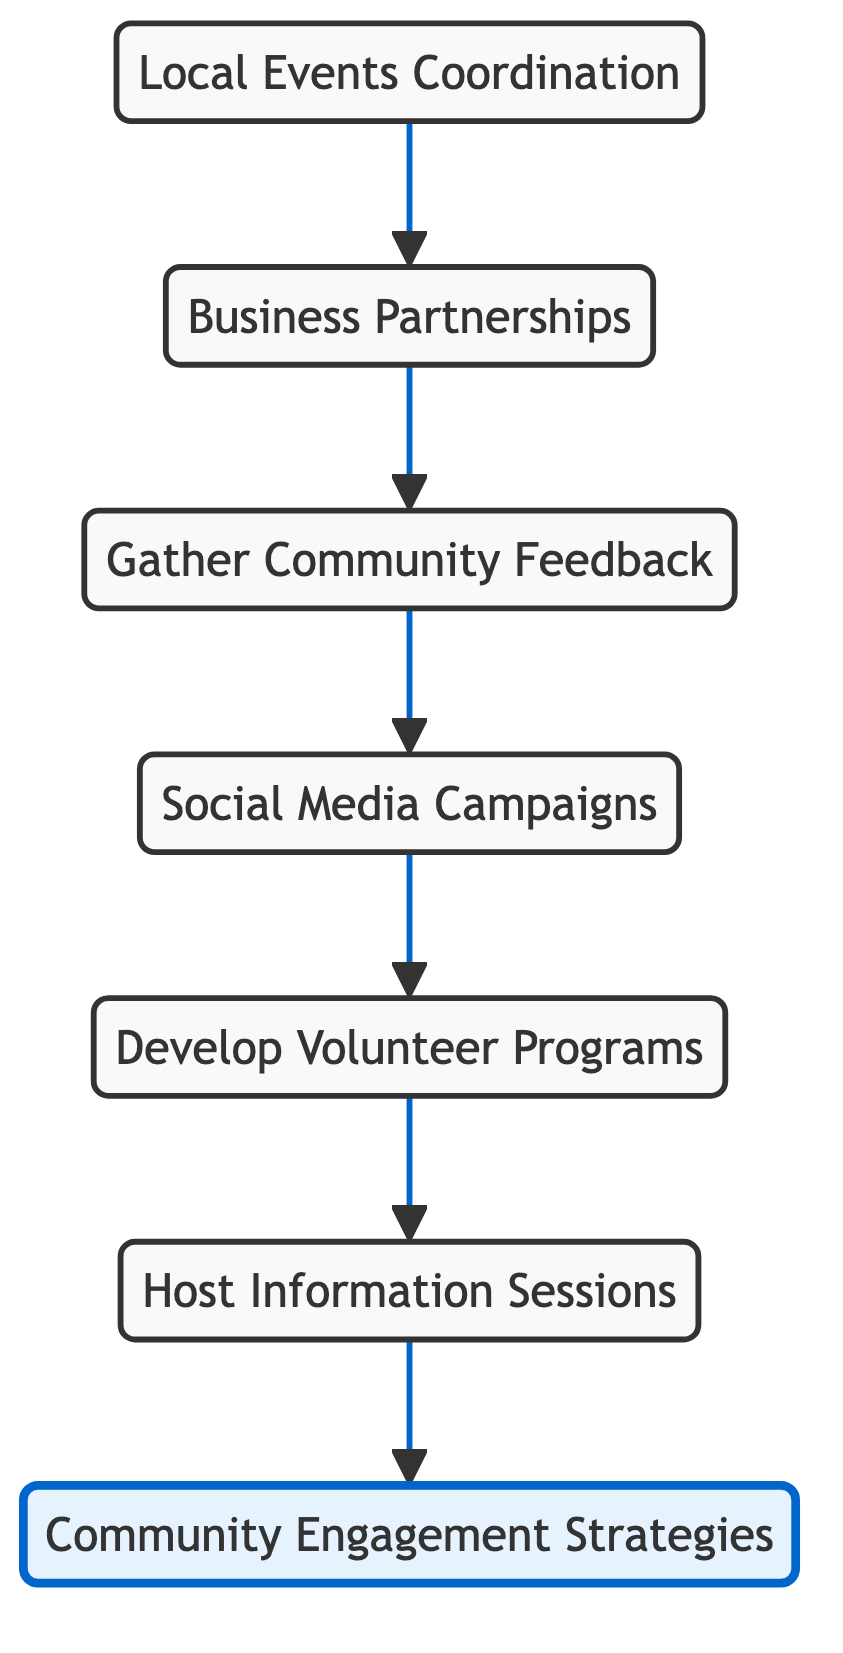What is the first step in the community engagement strategy? The diagram indicates that the first step is "Local Events Coordination," which is the starting node in the flow.
Answer: Local Events Coordination How many nodes are present in the diagram? By counting the unique elements listed in the diagram, we have six nodes: Local Events Coordination, Business Partnerships, Gather Community Feedback, Social Media Campaigns, Develop Volunteer Programs, and Host Information Sessions.
Answer: 6 What follows after gathering community feedback? The diagram shows that after "Gather Community Feedback," the next step is "Social Media Campaigns," indicating a flow from one activity to another.
Answer: Social Media Campaigns Which node directly leads to community engagement strategies? The "Information Sessions" node feeds into the "Community Engagement Strategies" node, making it the direct predecessor for this final outcome.
Answer: Information Sessions What type of initiatives are highlighted in the partnerships node? The Partnerships node emphasizes collaborating with local franchises for sponsorship and joint initiatives, which reflects a specific focus on business alignment within the community engagement strategy.
Answer: Collaborate with local franchises What is the last step in the flow of the diagram? Following the flow from the last defined step, it concludes at the "Community Engagement Strategies" node, which serves as the overarching goal of all previous activities.
Answer: Community Engagement Strategies Why is social media campaigns important in the strategy? The "Social Media Campaigns" node follows "Gather Community Feedback," meaning it uses the insights from community feedback to promote events effectively through social media platforms.
Answer: Promote events effectively What is the primary purpose of the volunteer programs? The "Develop Volunteer Programs" aims to create opportunities for residents to engage in community projects, directly involving them in local initiatives.
Answer: Create opportunities for residents What is the relationship between local events coordination and business partnerships? The relationship is sequential; the "Local Events Coordination" leads into "Business Partnerships," which means that coordinating events may involve collaborating with local businesses for support.
Answer: Local Events Coordination leads to Business Partnerships 